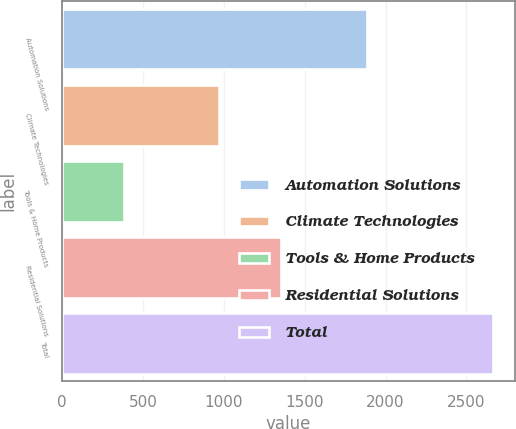Convert chart to OTSL. <chart><loc_0><loc_0><loc_500><loc_500><bar_chart><fcel>Automation Solutions<fcel>Climate Technologies<fcel>Tools & Home Products<fcel>Residential Solutions<fcel>Total<nl><fcel>1886<fcel>972<fcel>380<fcel>1352<fcel>2667<nl></chart> 